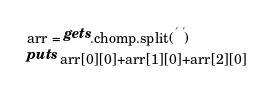Convert code to text. <code><loc_0><loc_0><loc_500><loc_500><_Ruby_>arr = gets.chomp.split(' ')
puts arr[0][0]+arr[1][0]+arr[2][0]</code> 